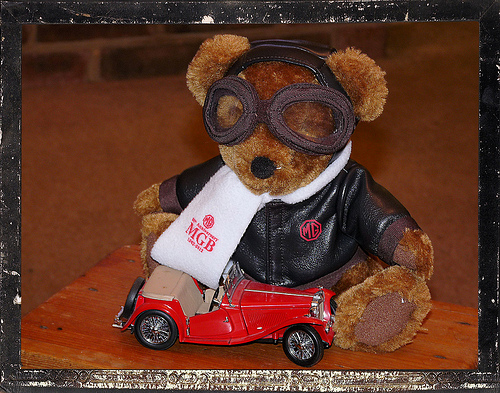<image>
Can you confirm if the coat is on the bear? Yes. Looking at the image, I can see the coat is positioned on top of the bear, with the bear providing support. Is there a bear behind the car? Yes. From this viewpoint, the bear is positioned behind the car, with the car partially or fully occluding the bear. Is there a car in front of the teddy car? Yes. The car is positioned in front of the teddy car, appearing closer to the camera viewpoint. 